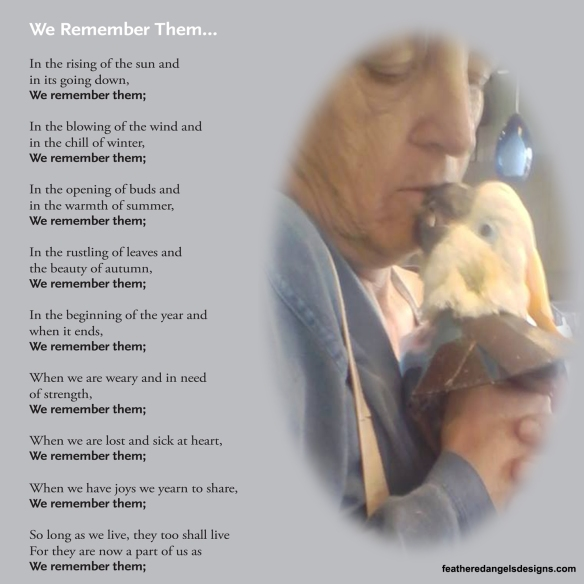Considering the emotional tone set by the poem and the intimate moment shared between the person and the bird, what might be the significance of the interaction depicted in the image, and how does it relate to the overall theme presented by the poem? The interaction depicted in the image, where the person is gently kissing the bird, signifies a profound sense of affection and bond between the two. The accompanying poem, which discusses remembering loved ones, suggests that the bird held a special place in the person's life, perhaps representing companionship and mutual affection. Together, the image and poem evoke a poignant sense of nostalgia and the enduring value of cherishing precious moments with those we love, whether human or animal. This interaction could symbolize a farewell or a token of everlasting love, perfectly complementing the poem's overarching theme of memory, love, and the continuity of emotional ties throughout the seasons and cycles of life. 